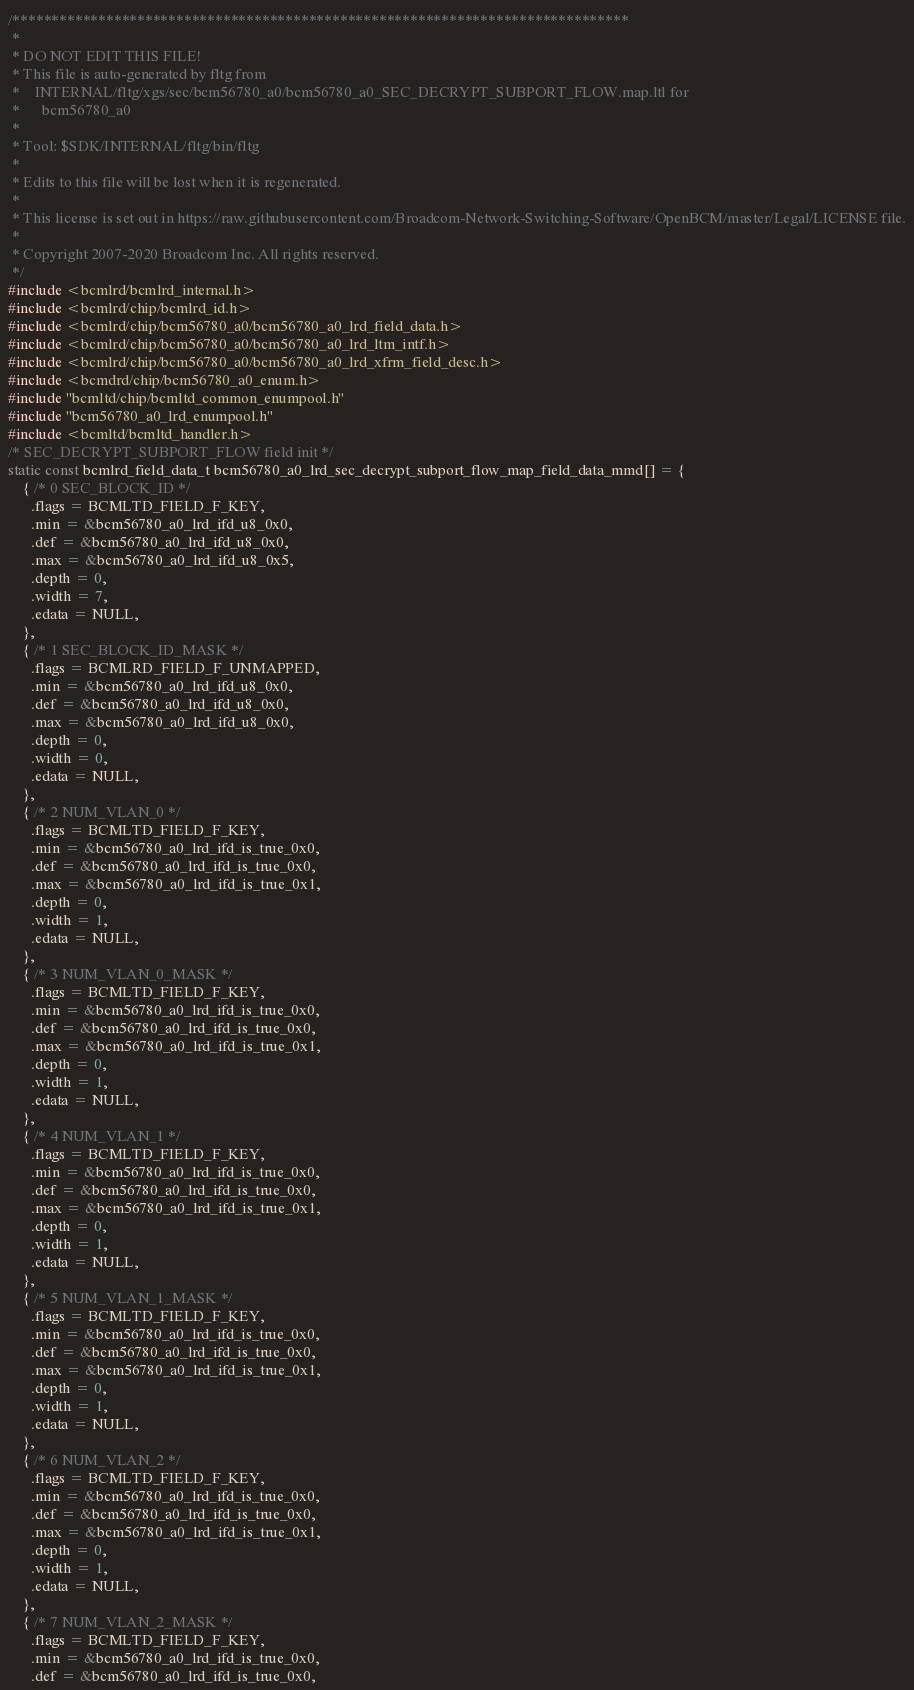<code> <loc_0><loc_0><loc_500><loc_500><_C_>/*******************************************************************************
 *
 * DO NOT EDIT THIS FILE!
 * This file is auto-generated by fltg from
 *    INTERNAL/fltg/xgs/sec/bcm56780_a0/bcm56780_a0_SEC_DECRYPT_SUBPORT_FLOW.map.ltl for
 *      bcm56780_a0
 *
 * Tool: $SDK/INTERNAL/fltg/bin/fltg
 *
 * Edits to this file will be lost when it is regenerated.
 *
 * This license is set out in https://raw.githubusercontent.com/Broadcom-Network-Switching-Software/OpenBCM/master/Legal/LICENSE file.
 * 
 * Copyright 2007-2020 Broadcom Inc. All rights reserved.
 */
#include <bcmlrd/bcmlrd_internal.h>
#include <bcmlrd/chip/bcmlrd_id.h>
#include <bcmlrd/chip/bcm56780_a0/bcm56780_a0_lrd_field_data.h>
#include <bcmlrd/chip/bcm56780_a0/bcm56780_a0_lrd_ltm_intf.h>
#include <bcmlrd/chip/bcm56780_a0/bcm56780_a0_lrd_xfrm_field_desc.h>
#include <bcmdrd/chip/bcm56780_a0_enum.h>
#include "bcmltd/chip/bcmltd_common_enumpool.h"
#include "bcm56780_a0_lrd_enumpool.h"
#include <bcmltd/bcmltd_handler.h>
/* SEC_DECRYPT_SUBPORT_FLOW field init */
static const bcmlrd_field_data_t bcm56780_a0_lrd_sec_decrypt_subport_flow_map_field_data_mmd[] = {
    { /* 0 SEC_BLOCK_ID */
      .flags = BCMLTD_FIELD_F_KEY,
      .min = &bcm56780_a0_lrd_ifd_u8_0x0,
      .def = &bcm56780_a0_lrd_ifd_u8_0x0,
      .max = &bcm56780_a0_lrd_ifd_u8_0x5,
      .depth = 0,
      .width = 7,
      .edata = NULL,
    },
    { /* 1 SEC_BLOCK_ID_MASK */
      .flags = BCMLRD_FIELD_F_UNMAPPED,
      .min = &bcm56780_a0_lrd_ifd_u8_0x0,
      .def = &bcm56780_a0_lrd_ifd_u8_0x0,
      .max = &bcm56780_a0_lrd_ifd_u8_0x0,
      .depth = 0,
      .width = 0,
      .edata = NULL,
    },
    { /* 2 NUM_VLAN_0 */
      .flags = BCMLTD_FIELD_F_KEY,
      .min = &bcm56780_a0_lrd_ifd_is_true_0x0,
      .def = &bcm56780_a0_lrd_ifd_is_true_0x0,
      .max = &bcm56780_a0_lrd_ifd_is_true_0x1,
      .depth = 0,
      .width = 1,
      .edata = NULL,
    },
    { /* 3 NUM_VLAN_0_MASK */
      .flags = BCMLTD_FIELD_F_KEY,
      .min = &bcm56780_a0_lrd_ifd_is_true_0x0,
      .def = &bcm56780_a0_lrd_ifd_is_true_0x0,
      .max = &bcm56780_a0_lrd_ifd_is_true_0x1,
      .depth = 0,
      .width = 1,
      .edata = NULL,
    },
    { /* 4 NUM_VLAN_1 */
      .flags = BCMLTD_FIELD_F_KEY,
      .min = &bcm56780_a0_lrd_ifd_is_true_0x0,
      .def = &bcm56780_a0_lrd_ifd_is_true_0x0,
      .max = &bcm56780_a0_lrd_ifd_is_true_0x1,
      .depth = 0,
      .width = 1,
      .edata = NULL,
    },
    { /* 5 NUM_VLAN_1_MASK */
      .flags = BCMLTD_FIELD_F_KEY,
      .min = &bcm56780_a0_lrd_ifd_is_true_0x0,
      .def = &bcm56780_a0_lrd_ifd_is_true_0x0,
      .max = &bcm56780_a0_lrd_ifd_is_true_0x1,
      .depth = 0,
      .width = 1,
      .edata = NULL,
    },
    { /* 6 NUM_VLAN_2 */
      .flags = BCMLTD_FIELD_F_KEY,
      .min = &bcm56780_a0_lrd_ifd_is_true_0x0,
      .def = &bcm56780_a0_lrd_ifd_is_true_0x0,
      .max = &bcm56780_a0_lrd_ifd_is_true_0x1,
      .depth = 0,
      .width = 1,
      .edata = NULL,
    },
    { /* 7 NUM_VLAN_2_MASK */
      .flags = BCMLTD_FIELD_F_KEY,
      .min = &bcm56780_a0_lrd_ifd_is_true_0x0,
      .def = &bcm56780_a0_lrd_ifd_is_true_0x0,</code> 